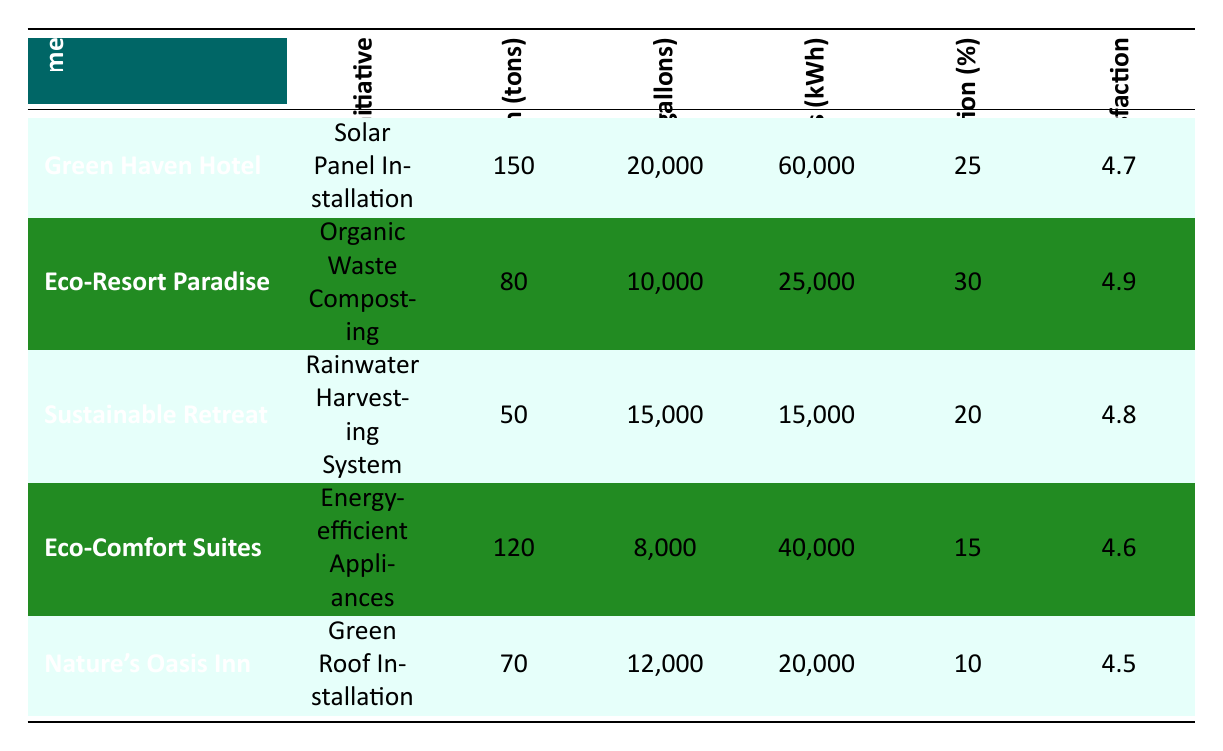What is the Carbon Reduction for the Green Haven Hotel? The data for the Green Haven Hotel shows that it has a Carbon Reduction of 150 tons.
Answer: 150 tons Which hotel has the highest Guest Satisfaction Score? The table shows the Guest Satisfaction Scores for each hotel. The highest score is 4.9 for Eco-Resort Paradise.
Answer: 4.9 What is the total Water Savings (in gallons) achieved by Eco-Comfort Suites and Nature’s Oasis Inn? Eco-Comfort Suites has Water Savings of 8,000 gallons and Nature's Oasis Inn has 12,000 gallons. The total is 8,000 + 12,000 = 20,000 gallons.
Answer: 20,000 gallons Is the Waste Reduction percentage for Sustainable Retreat less than 25%? The Waste Reduction percentage for Sustainable Retreat is 20%, which is indeed less than 25%.
Answer: Yes What is the average Energy Savings (in kWh) across all hotels? The Energy Savings are 60,000, 25,000, 15,000, 40,000, and 20,000 kWh for the respective hotels. The total Energy Savings is 60,000 + 25,000 + 15,000 + 40,000 + 20,000 = 160,000 kWh. Dividing by 5 hotels gives an average of 160,000 / 5 = 32,000 kWh.
Answer: 32,000 kWh Which initiative achieved the least Water Savings? The table lists the Water Savings for each initiative. Eco-Comfort Suites has the least Water Savings of 8,000 gallons.
Answer: 8,000 gallons Does the Eco-Resort Paradise have a higher Carbon Reduction than Nature's Oasis Inn? Eco-Resort Paradise has a Carbon Reduction of 80 tons, while Nature’s Oasis Inn has 70 tons. Since 80 is greater than 70, the statement is true.
Answer: Yes What is the difference in Carbon Reduction between the Green Haven Hotel and Eco-Comfort Suites? The Carbon Reduction for Green Haven Hotel is 150 tons and for Eco-Comfort Suites it is 120 tons. The difference is 150 - 120 = 30 tons.
Answer: 30 tons What initiative resulted in the most Energy Savings? By comparing the Energy Savings, Green Haven Hotel’s Solar Panel Installation yielded 60,000 kWh, more than any other initiative listed.
Answer: Solar Panel Installation What percentage of Waste Reduction did the Eco-Resort Paradise achieve? According to the table, Eco-Resort Paradise achieved a Waste Reduction of 30%.
Answer: 30% 